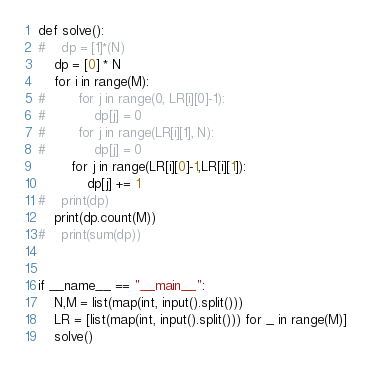Convert code to text. <code><loc_0><loc_0><loc_500><loc_500><_Python_>
def solve():
#    dp = [1]*(N)
    dp = [0] * N
    for i in range(M):
#        for j in range(0, LR[i][0]-1):
#            dp[j] = 0
#        for j in range(LR[i][1], N):
#            dp[j] = 0
        for j in range(LR[i][0]-1,LR[i][1]):
            dp[j] += 1
#    print(dp)
    print(dp.count(M))
#    print(sum(dp))


if __name__ == "__main__":
    N,M = list(map(int, input().split()))
    LR = [list(map(int, input().split())) for _ in range(M)]
    solve()  
</code> 